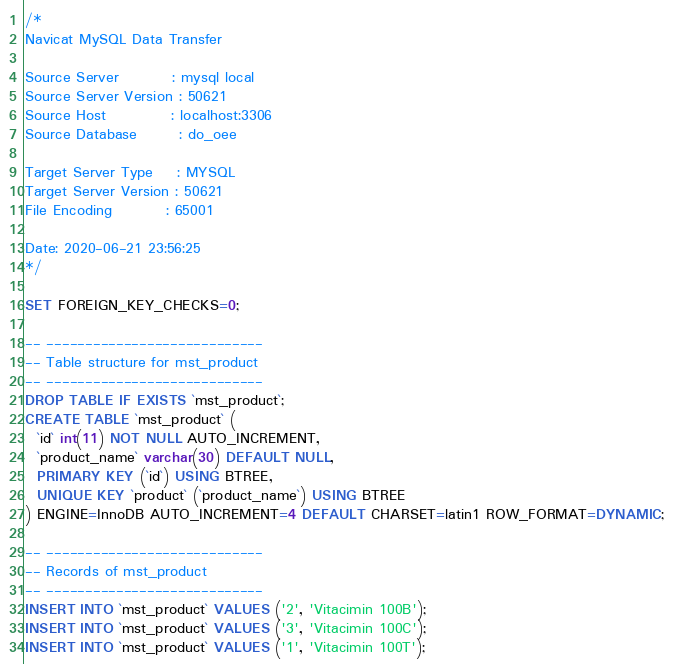<code> <loc_0><loc_0><loc_500><loc_500><_SQL_>/*
Navicat MySQL Data Transfer

Source Server         : mysql local
Source Server Version : 50621
Source Host           : localhost:3306
Source Database       : do_oee

Target Server Type    : MYSQL
Target Server Version : 50621
File Encoding         : 65001

Date: 2020-06-21 23:56:25
*/

SET FOREIGN_KEY_CHECKS=0;

-- ----------------------------
-- Table structure for mst_product
-- ----------------------------
DROP TABLE IF EXISTS `mst_product`;
CREATE TABLE `mst_product` (
  `id` int(11) NOT NULL AUTO_INCREMENT,
  `product_name` varchar(30) DEFAULT NULL,
  PRIMARY KEY (`id`) USING BTREE,
  UNIQUE KEY `product` (`product_name`) USING BTREE
) ENGINE=InnoDB AUTO_INCREMENT=4 DEFAULT CHARSET=latin1 ROW_FORMAT=DYNAMIC;

-- ----------------------------
-- Records of mst_product
-- ----------------------------
INSERT INTO `mst_product` VALUES ('2', 'Vitacimin 100B');
INSERT INTO `mst_product` VALUES ('3', 'Vitacimin 100C');
INSERT INTO `mst_product` VALUES ('1', 'Vitacimin 100T');
</code> 